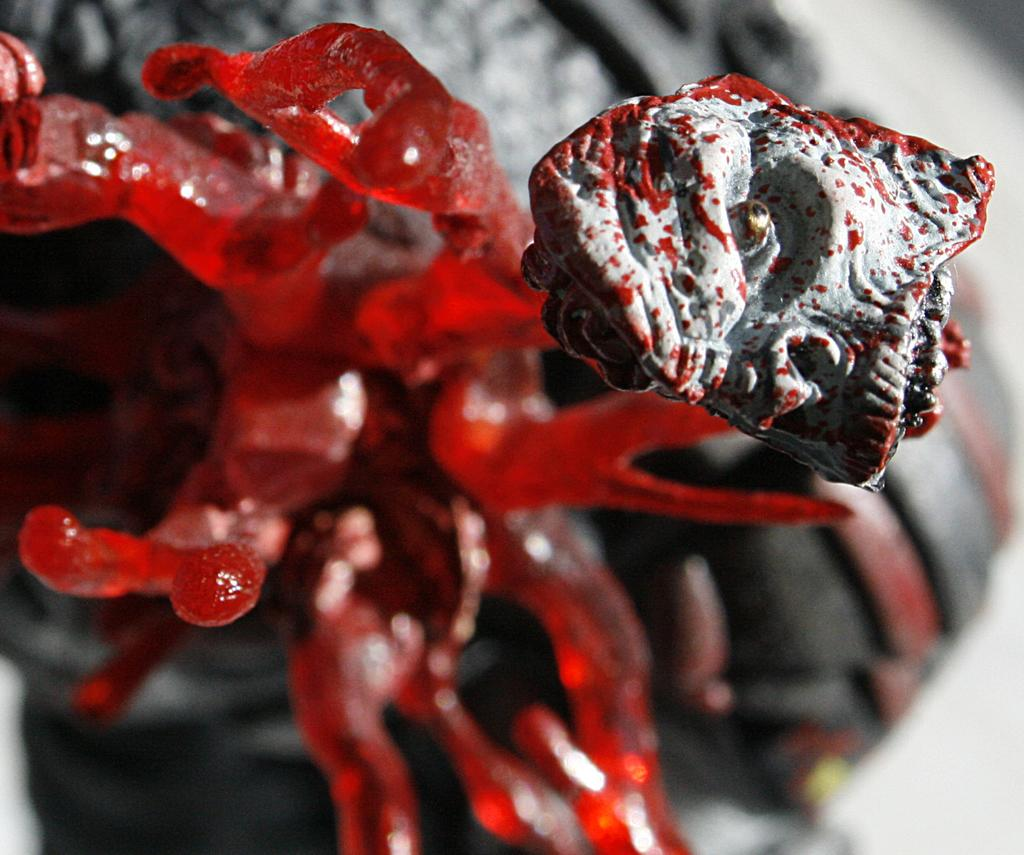What is the main object in the image? There is a stone in the image. How is the stone decorated? The stone is painted with white and red color. What other item can be seen in the image? There is a plastic plant in the image. What is the purpose of the plastic plant? The plastic plant is a decorative item. What type of dress is the stone wearing in the image? The stone is not wearing a dress, as it is an inanimate object and does not have the ability to wear clothing. 